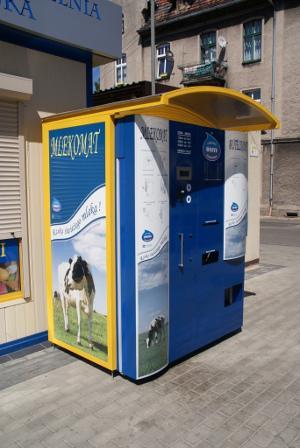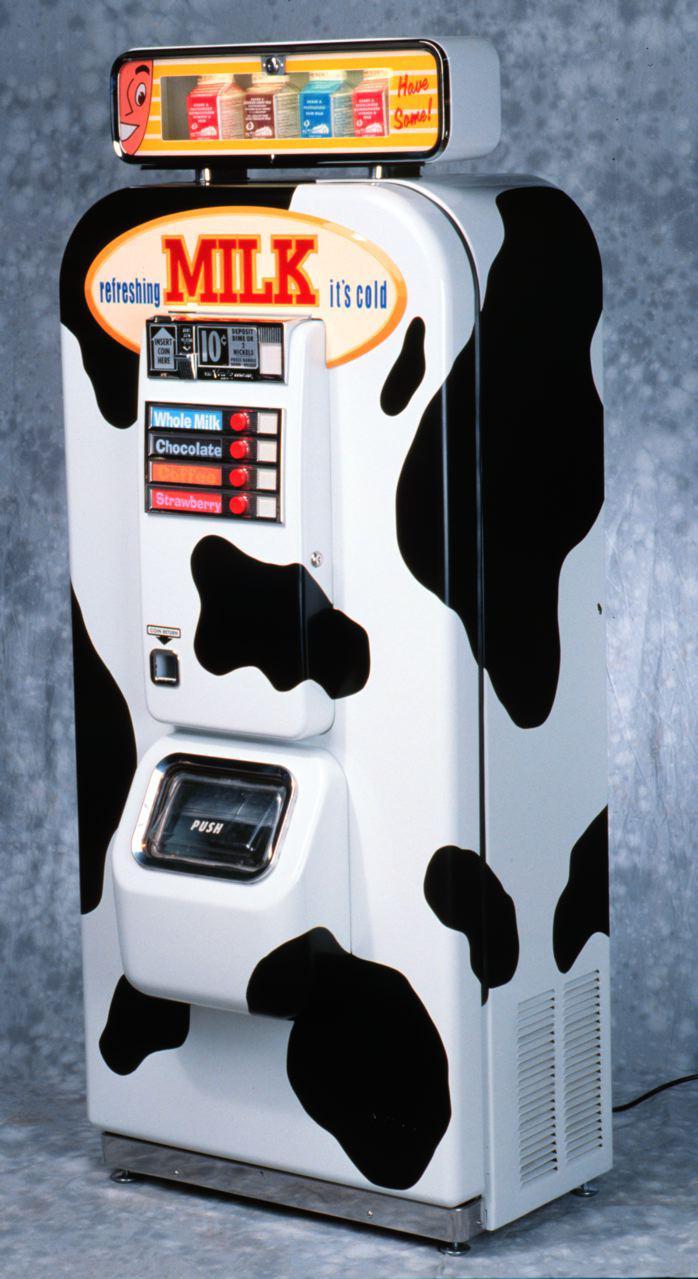The first image is the image on the left, the second image is the image on the right. Examine the images to the left and right. Is the description "A vending machine has distinctive black and white markings." accurate? Answer yes or no. Yes. 